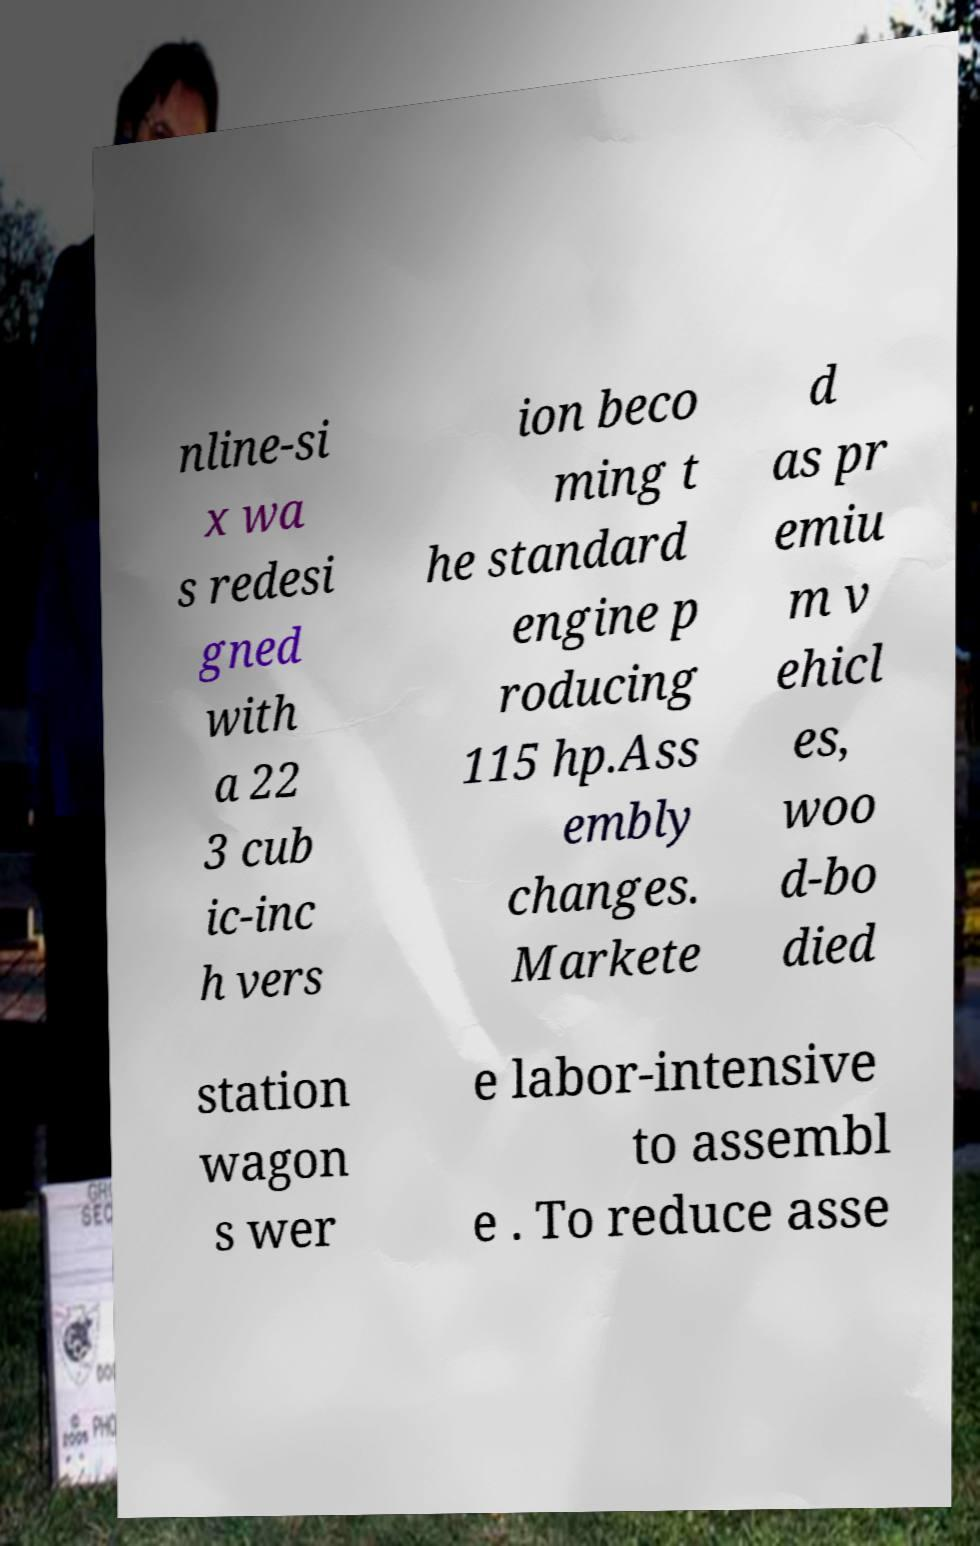Can you read and provide the text displayed in the image?This photo seems to have some interesting text. Can you extract and type it out for me? nline-si x wa s redesi gned with a 22 3 cub ic-inc h vers ion beco ming t he standard engine p roducing 115 hp.Ass embly changes. Markete d as pr emiu m v ehicl es, woo d-bo died station wagon s wer e labor-intensive to assembl e . To reduce asse 